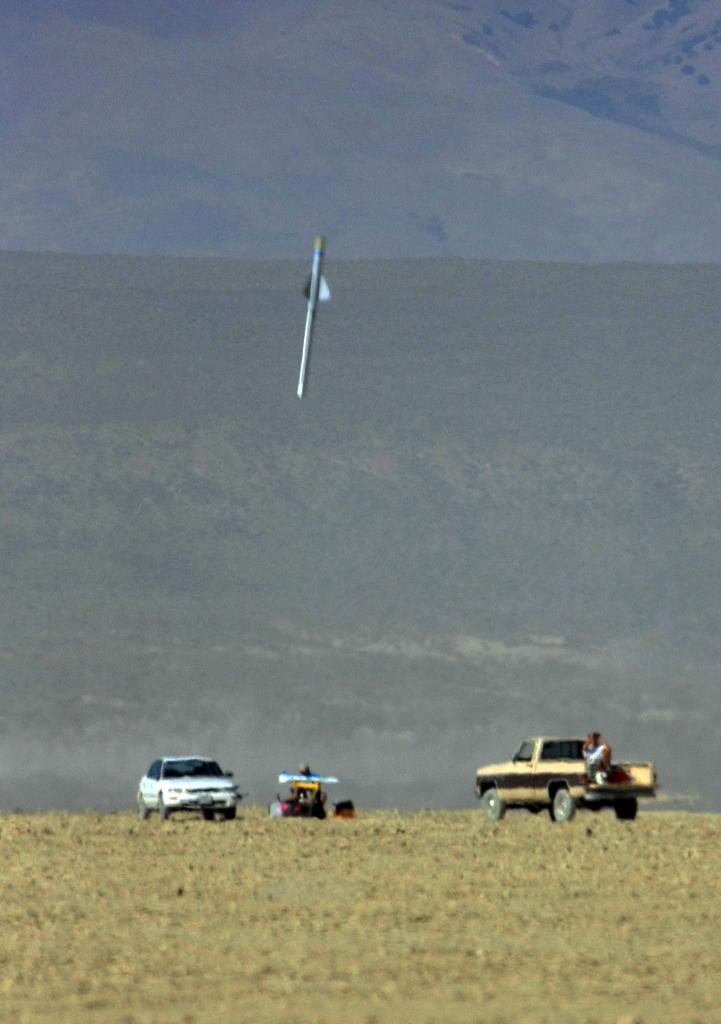What is flying in the air in the image? There is a missile in the air in the image. What can be seen on the ground in the image? Vehicles are visible on the ground. What type of landscape is visible in the background of the image? There are hills in the background of the image. What type of music can be heard playing in the image? There is no music present in the image; it is a still image of a missile in the air and vehicles on the ground. 